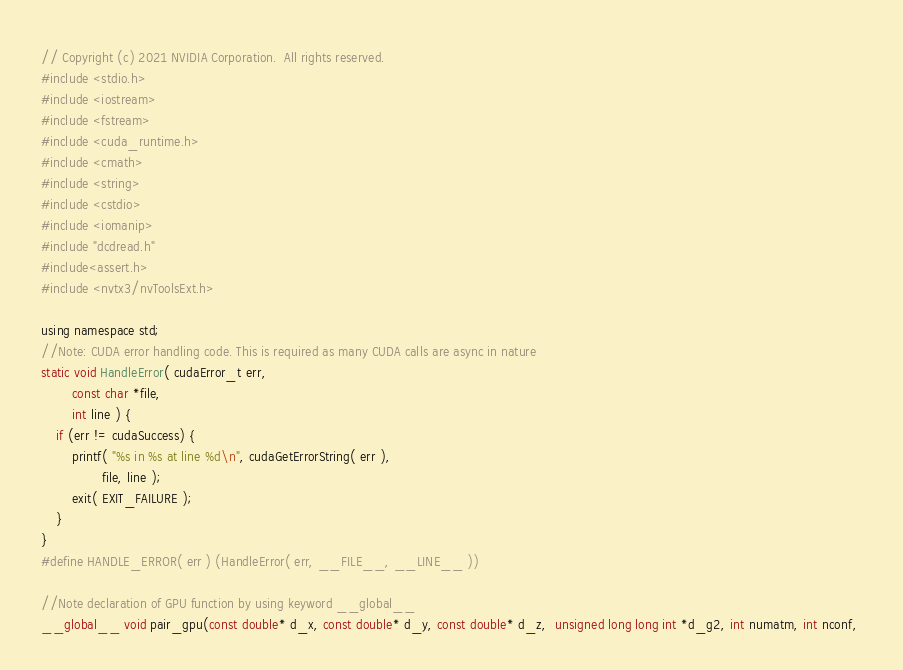Convert code to text. <code><loc_0><loc_0><loc_500><loc_500><_Cuda_>// Copyright (c) 2021 NVIDIA Corporation.  All rights reserved. 
#include <stdio.h>
#include <iostream>
#include <fstream>
#include <cuda_runtime.h>
#include <cmath>
#include <string>
#include <cstdio>
#include <iomanip>
#include "dcdread.h"
#include<assert.h>
#include <nvtx3/nvToolsExt.h>

using namespace std;
//Note: CUDA error handling code. This is required as many CUDA calls are async in nature
static void HandleError( cudaError_t err,
		const char *file,
		int line ) {
	if (err != cudaSuccess) {
		printf( "%s in %s at line %d\n", cudaGetErrorString( err ),
				file, line );
		exit( EXIT_FAILURE );
	}
}
#define HANDLE_ERROR( err ) (HandleError( err, __FILE__, __LINE__ ))

//Note declaration of GPU function by using keyword __global__
__global__ void pair_gpu(const double* d_x, const double* d_y, const double* d_z,  unsigned long long int *d_g2, int numatm, int nconf, </code> 